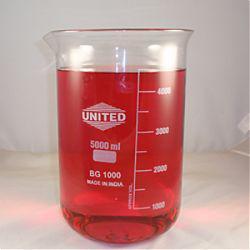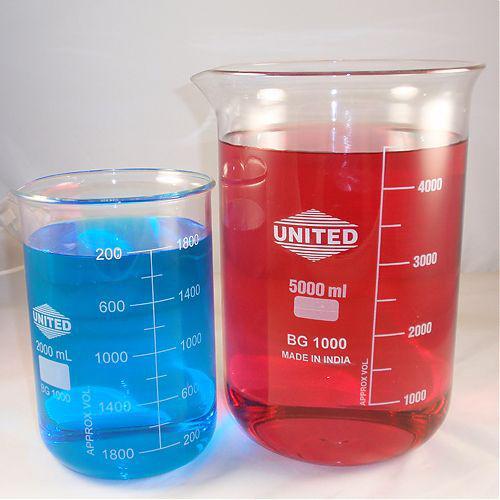The first image is the image on the left, the second image is the image on the right. Analyze the images presented: Is the assertion "One of the images shows an empty flask and the other image shows a flask containing liquid." valid? Answer yes or no. No. The first image is the image on the left, the second image is the image on the right. For the images displayed, is the sentence "One of the images contains a flask rather than a beaker." factually correct? Answer yes or no. No. The first image is the image on the left, the second image is the image on the right. Evaluate the accuracy of this statement regarding the images: "In at least one image there is one clear beaker bong with glass mouth peice.". Is it true? Answer yes or no. No. The first image is the image on the left, the second image is the image on the right. Given the left and right images, does the statement "Each image contains colored liquid in a container, and at least one image includes a beaker without a handle containing red liquid." hold true? Answer yes or no. Yes. 